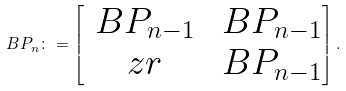<formula> <loc_0><loc_0><loc_500><loc_500>\ B P _ { n } \colon = \begin{bmatrix} \ B P _ { n - 1 } & \ B P _ { n - 1 } \\ \ z r & \ B P _ { n - 1 } \end{bmatrix} .</formula> 